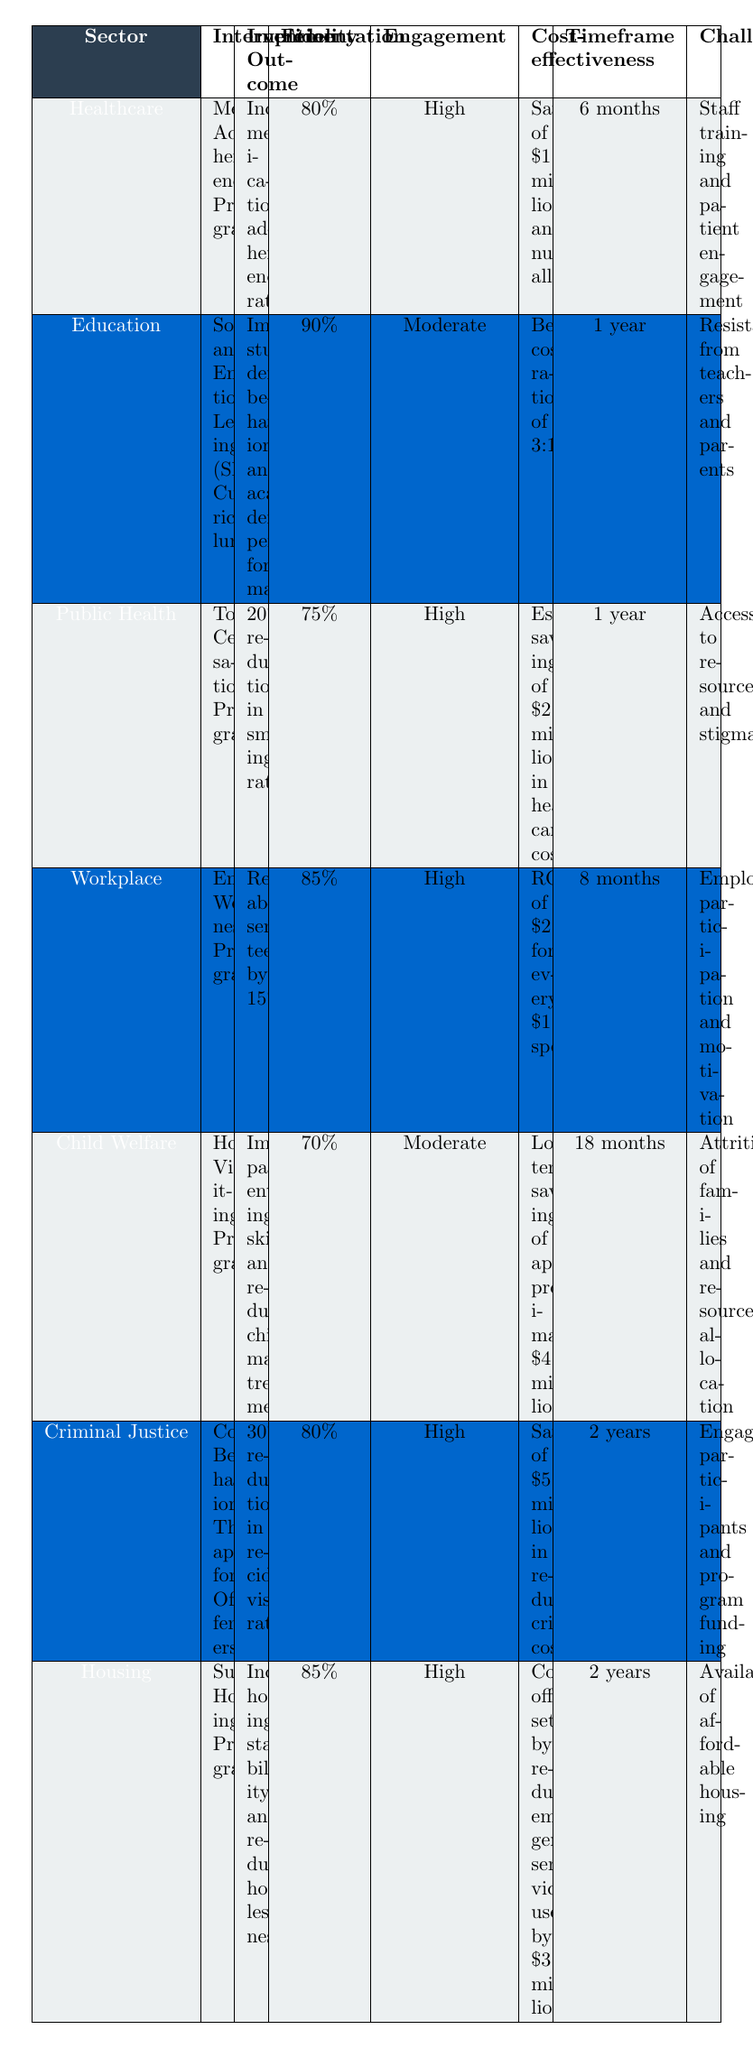What is the Implementation Fidelity of the 'Tobacco Cessation Program'? The table indicates the Implementation Fidelity for the 'Tobacco Cessation Program' under the Public Health sector, which is stated as 75%.
Answer: 75% Which intervention has the highest Implementation Fidelity? By reviewing the table, the 'Social and Emotional Learning (SEL) Curriculum' in the Education sector has the highest Implementation Fidelity listed at 90%.
Answer: Social and Emotional Learning (SEL) Curriculum Is the Stakeholder Engagement for the 'Home Visiting Program' classified as High? The table shows that the Stakeholder Engagement for the 'Home Visiting Program' in the Child Welfare sector is marked as Moderate, not High.
Answer: No How much annual savings is associated with the 'Employee Wellness Program'? The cost-effectiveness of the 'Employee Wellness Program' indicates an ROI of $2.3 for every $1 spent, which does not directly give an annual saving amount, so it requires further context. Without specific spending figures, we cannot derive a precise savings amount.
Answer: Not determinable from the table What is the average Implementation Fidelity across all interventions? The Implementation Fidelity values are 80%, 90%, 75%, 85%, 70%, 80%, and 85%. Adding these gives 575%, and dividing by 7 (the number of interventions) results in approximately 82.14%.
Answer: 82.14% What challenges do the 'Cognitive Behavioral Therapy for Offenders' program and the 'Tobacco Cessation Program' share? The challenges for 'Cognitive Behavioral Therapy for Offenders' include engaging participants and program funding, while the 'Tobacco Cessation Program' faces access to resources and stigma. These challenges are different, indicating they do not share any common challenges.
Answer: No shared challenges Which sector shows the most significant cost-effectiveness in monetary terms? The 'Cognitive Behavioral Therapy for Offenders' program shows savings of $5 million in reduced crime costs, the highest among all listed sectors, indicating it has the most significant cost-effectiveness in monetary terms.
Answer: Criminal Justice sector In how many months is the 'Chief Welfare Program' expected to show effectiveness? The 'Home Visiting Program' in the Child Welfare sector is expected to show effectiveness over a timeframe of 18 months.
Answer: 18 months What is the benefit-cost ratio of the 'Social and Emotional Learning (SEL) Curriculum'? The benefit-cost ratio for the 'Social and Emotional Learning (SEL) Curriculum' is stated as 3:1 in the table, meaning for every dollar spent, there is a return of three dollars.
Answer: 3:1 How do the Implementation Outcomes of the 'Supportive Housing Program' and the 'Medication Adherence Program' compare? The 'Supportive Housing Program' reports increased housing stability and reduced homelessness, while the 'Medication Adherence Program' reports increased medication adherence rates. Both suggest positive outcomes but in different areas.
Answer: Both are positive but different outcomes Which intervention has the lowest stakeholder engagement? The 'Social and Emotional Learning (SEL) Curriculum' has Moderate engagement listed as compared to others, making it the one with the lowest stakeholder engagement level.
Answer: Social and Emotional Learning (SEL) Curriculum 